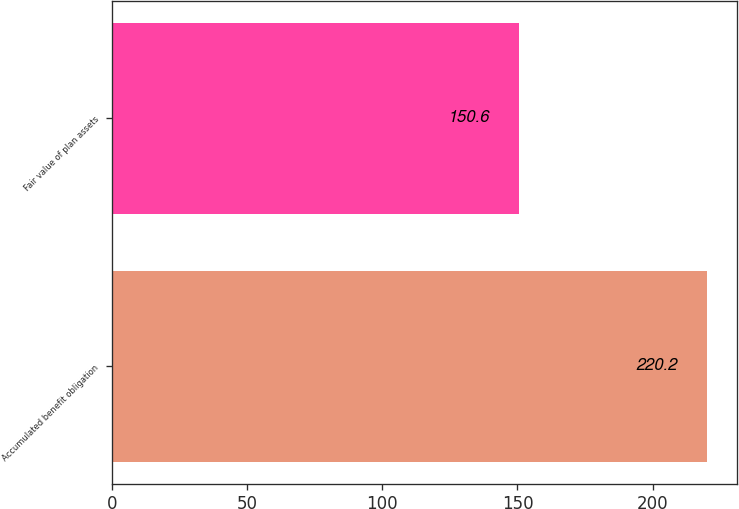Convert chart. <chart><loc_0><loc_0><loc_500><loc_500><bar_chart><fcel>Accumulated benefit obligation<fcel>Fair value of plan assets<nl><fcel>220.2<fcel>150.6<nl></chart> 